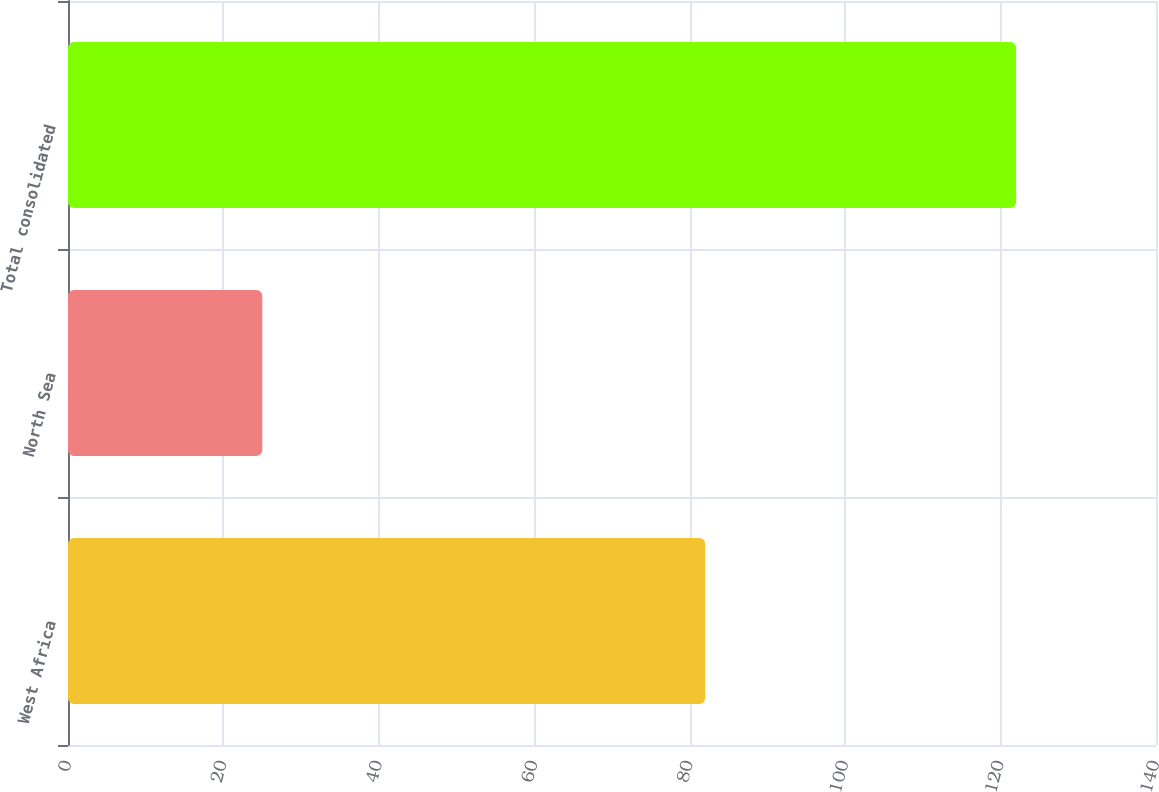Convert chart. <chart><loc_0><loc_0><loc_500><loc_500><bar_chart><fcel>West Africa<fcel>North Sea<fcel>Total consolidated<nl><fcel>82<fcel>25<fcel>122<nl></chart> 